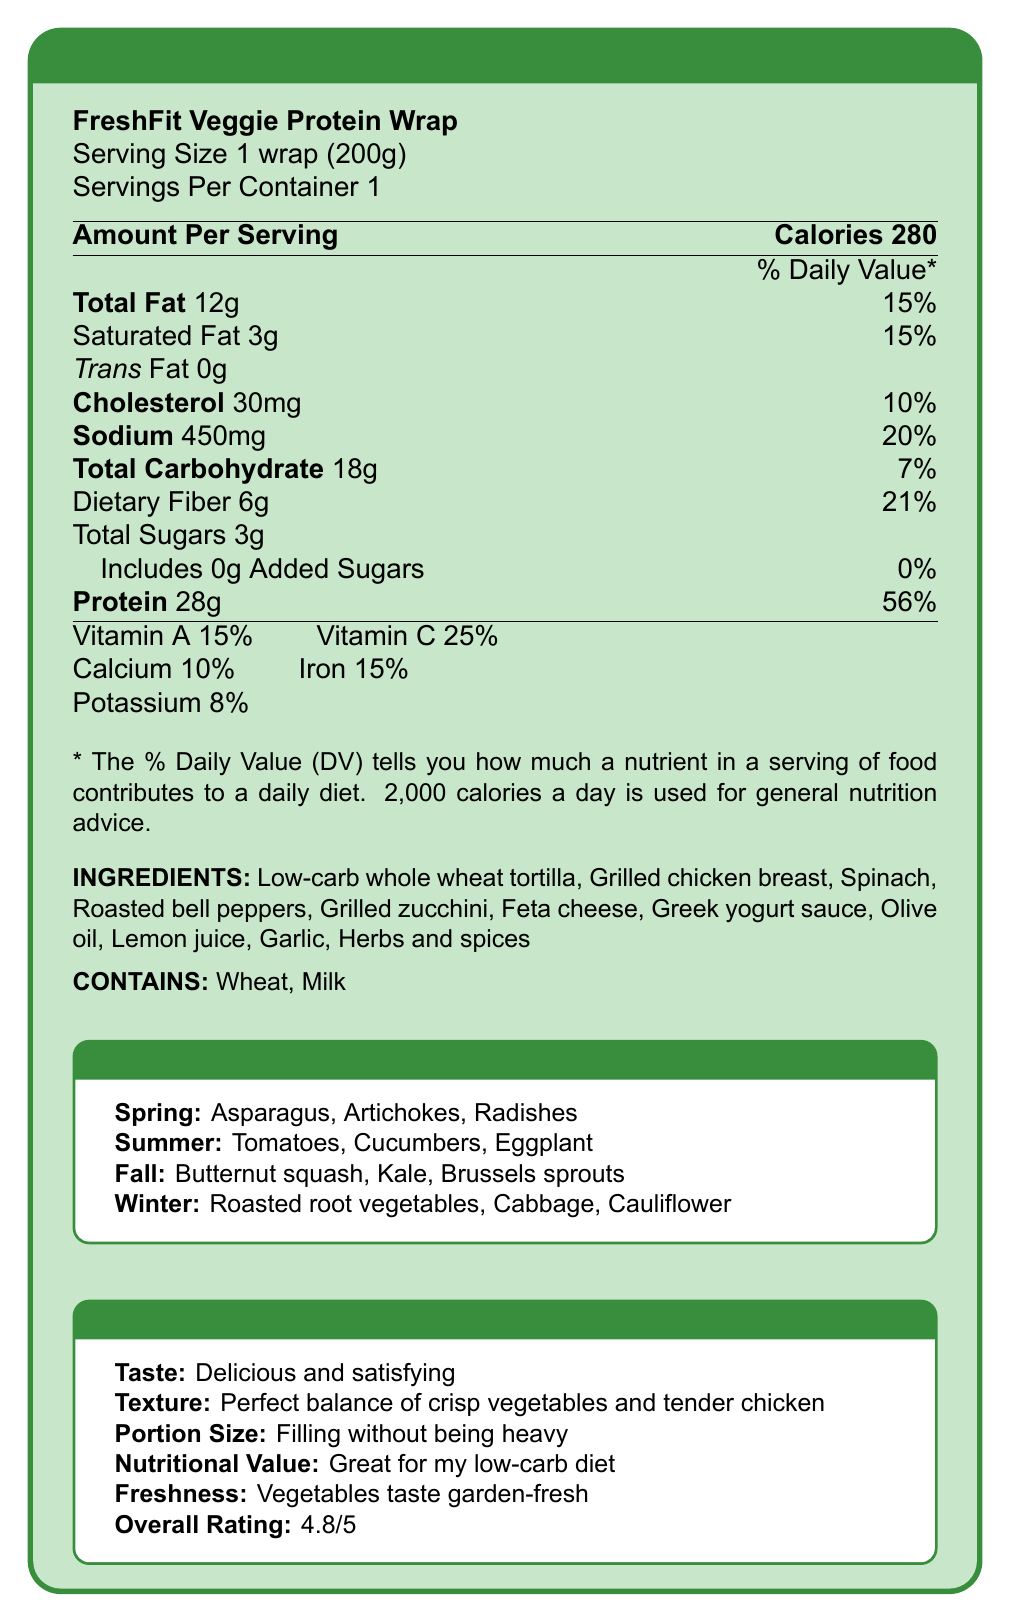what is the serving size of the FreshFit Veggie Protein Wrap? The serving size is explicitly stated as "1 wrap (200g)" in the document.
Answer: 1 wrap (200g) how many calories are in one serving of the wrap? The document states that there are 280 calories in a serving.
Answer: 280 calories what is the total fat content and its daily value percentage? The total fat content is 12g, which contributes 15% to the daily value as mentioned in the document.
Answer: 12g, 15% how much protein does this wrap contain? The document lists the protein content as 28g per serving.
Answer: 28g which season features tomatoes in the seasonal variations? The seasonal variations section lists tomatoes as one of the summer vegetables.
Answer: Summer how is the texture of the FreshFit Veggie Protein Wrap described in the customer feedback? The customer feedback section describes the texture as having a "Perfect balance of crisp vegetables and tender chicken".
Answer: Perfect balance of crisp vegetables and tender chicken what percentage of the daily value of sodium does one serving provide? One serving provides 450mg of sodium, which is 20% of the daily value.
Answer: 20% does the wrap contain any added sugars? The document states that the wrap includes 0g of Added Sugars.
Answer: No what is the amount of dietary fiber in the wrap? The dietary fiber content is listed as 6g.
Answer: 6g describe the main idea of the FreshFit Veggie Protein Wrap document. The document starts with the Nutrition Facts, listing calories, macronutrients, and daily values. It then mentions ingredients, allergens, customer feedback on taste, texture, and overall impression, and finally highlights vegetables that are used based on the season.
Answer: The document provides detailed nutritional information about the FreshFit Veggie Protein Wrap, including calorie and macronutrient content, vitamins and minerals, ingredients, allergens, customer feedback, and seasonal variations in the vegetables used. if someone is allergic to dairy, is this wrap suitable for them? The document notes that the wrap contains milk, which makes it unsuitable for individuals with dairy allergies.
Answer: No what vitamins are present in the FreshFit Veggie Protein Wrap and their respective daily values? These vitamin daily values are listed in the document under the Nutrition Facts section.
Answer: Vitamin A: 15%, Vitamin C: 25%, Calcium: 10%, Iron: 15%, Potassium: 8% which ingredient is not listed in the FreshFit Veggie Protein Wrap? A. Spinach B. Tomato C. Garlic The ingredients list includes Spinach and Garlic, but Tomato is not among them.
Answer: B. Tomato which of the following statements is true based on the document? A. The wrap contains gluten. B. The wrap contains nuts. C. The wrap contains shellfish. The allergens listed in the document are Wheat and Milk, indicating gluten presence from wheat.
Answer: A. The wrap contains gluten. is this wrap filling without being heavy according to customer feedback? Customer feedback describes the portion size as "Filling without being heavy."
Answer: Yes which vitamin has the lowest daily value percentage provided by this wrap? A. Vitamin A B. Vitamin C C. Calcium D. Iron E. Potassium The document shows that Potassium has an 8% daily value, the lowest among the listed vitamins and minerals.
Answer: E. Potassium where is the wrap’s cholesterol content mentioned? The document lists cholesterol content as 30mg which is 10% of the daily value.
Answer: 30mg, 10% which vegetable is not listed in any of the seasonal variations? The document lists various vegetables for different seasons, but Okra is not mentioned in any season.
Answer: Okra what is the overall customer rating of the wrap? The overall customer rating is provided as 4.8 out of 5 in the customer feedback section.
Answer: 4.8 does the document provide the shelf life of the wrap? The document does not mention the shelf life of the FreshFit Veggie Protein Wrap.
Answer: Not enough information 